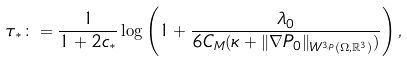<formula> <loc_0><loc_0><loc_500><loc_500>\tau _ { \ast } \colon = \frac { 1 } { 1 + 2 c _ { \ast } } \log \left ( 1 + \frac { \lambda _ { 0 } } { 6 C _ { M } ( \kappa + \| \nabla P _ { 0 } \| _ { W ^ { 3 , p } ( \Omega , \mathbb { R } ^ { 3 } ) } ) } \right ) ,</formula> 